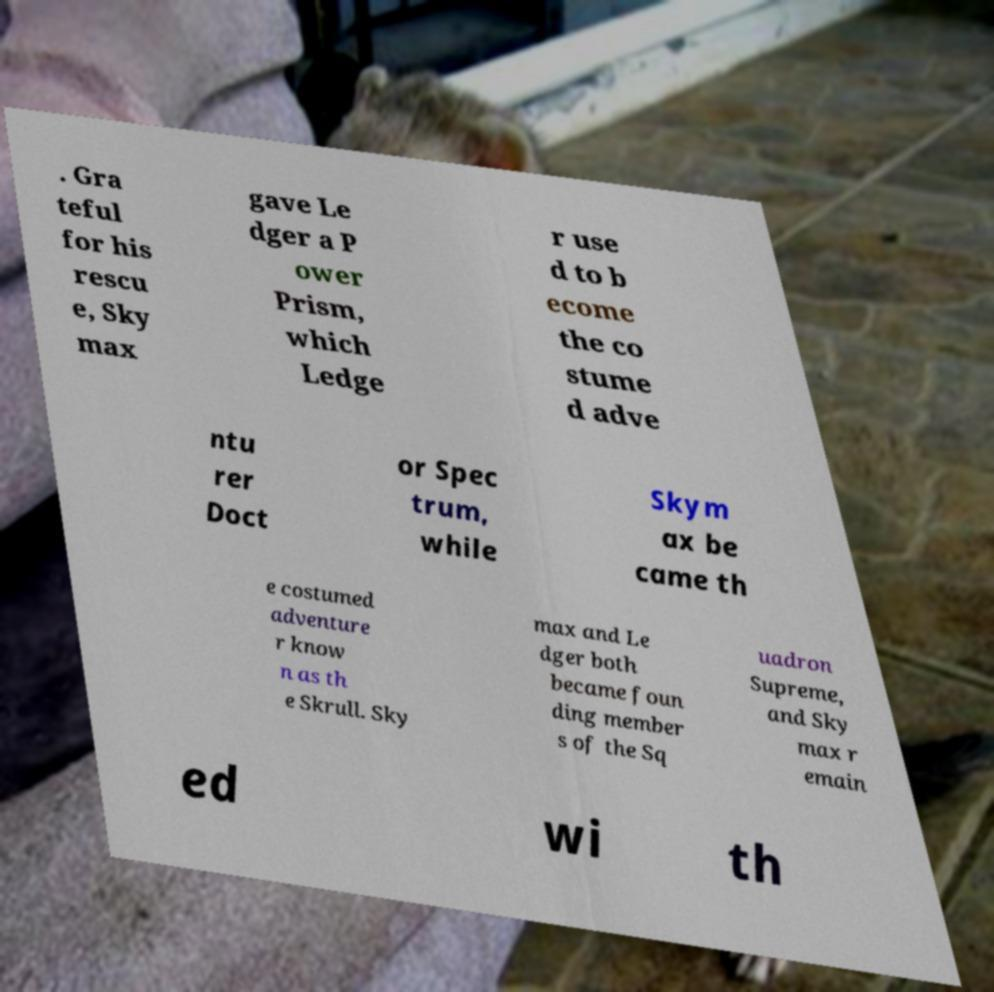Please identify and transcribe the text found in this image. . Gra teful for his rescu e, Sky max gave Le dger a P ower Prism, which Ledge r use d to b ecome the co stume d adve ntu rer Doct or Spec trum, while Skym ax be came th e costumed adventure r know n as th e Skrull. Sky max and Le dger both became foun ding member s of the Sq uadron Supreme, and Sky max r emain ed wi th 